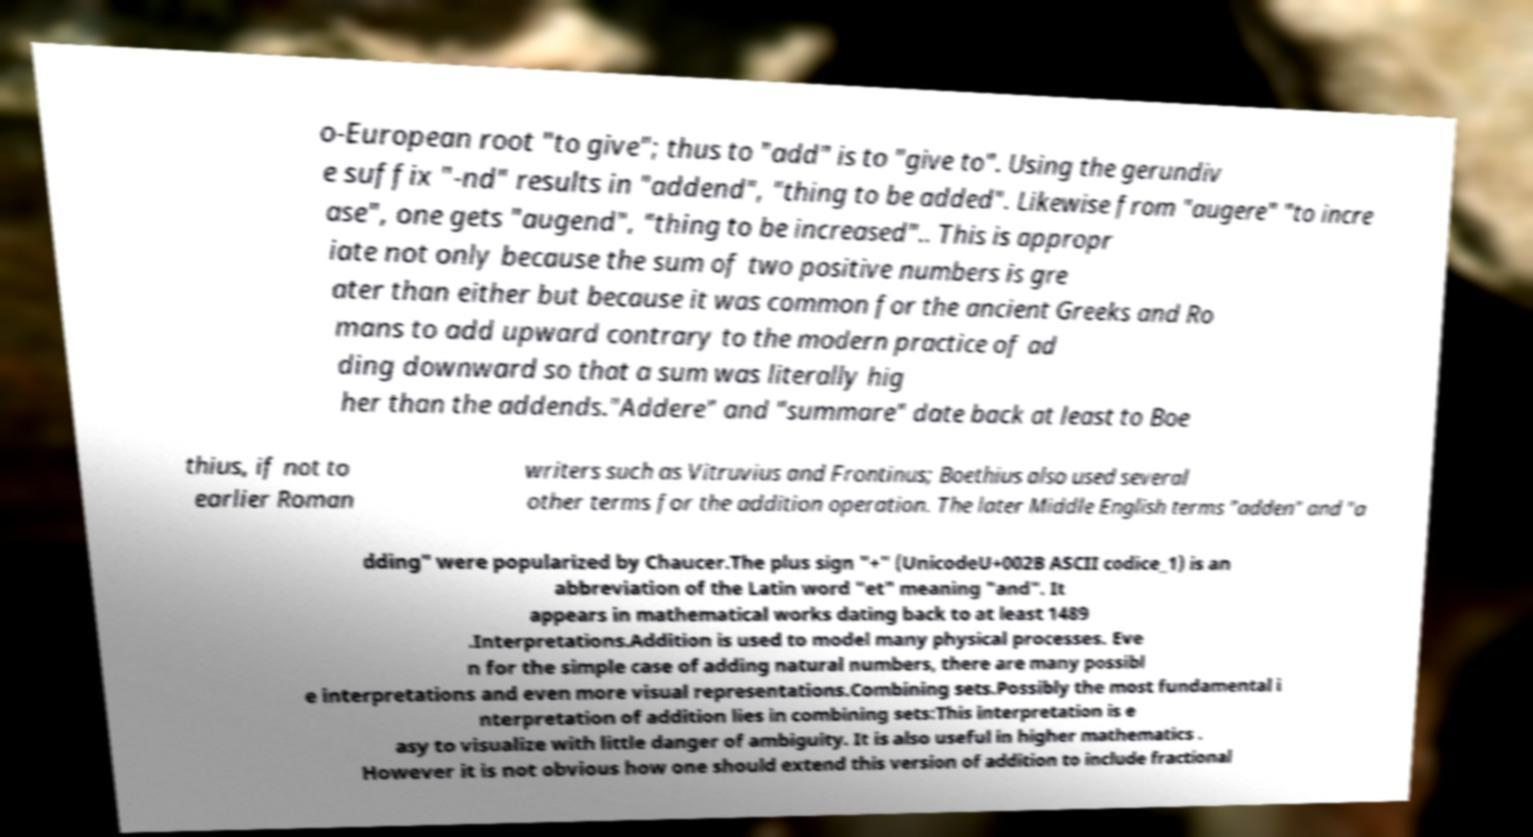Can you read and provide the text displayed in the image?This photo seems to have some interesting text. Can you extract and type it out for me? o-European root "to give"; thus to "add" is to "give to". Using the gerundiv e suffix "-nd" results in "addend", "thing to be added". Likewise from "augere" "to incre ase", one gets "augend", "thing to be increased".. This is appropr iate not only because the sum of two positive numbers is gre ater than either but because it was common for the ancient Greeks and Ro mans to add upward contrary to the modern practice of ad ding downward so that a sum was literally hig her than the addends."Addere" and "summare" date back at least to Boe thius, if not to earlier Roman writers such as Vitruvius and Frontinus; Boethius also used several other terms for the addition operation. The later Middle English terms "adden" and "a dding" were popularized by Chaucer.The plus sign "+" (UnicodeU+002B ASCII codice_1) is an abbreviation of the Latin word "et" meaning "and". It appears in mathematical works dating back to at least 1489 .Interpretations.Addition is used to model many physical processes. Eve n for the simple case of adding natural numbers, there are many possibl e interpretations and even more visual representations.Combining sets.Possibly the most fundamental i nterpretation of addition lies in combining sets:This interpretation is e asy to visualize with little danger of ambiguity. It is also useful in higher mathematics . However it is not obvious how one should extend this version of addition to include fractional 